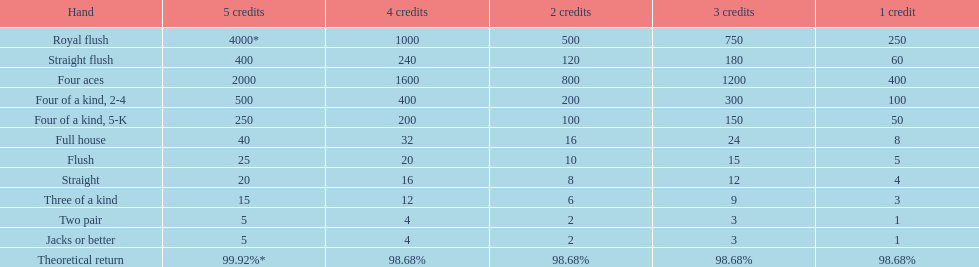Can a 2-credit full house be compared to a 5-credit three of a kind in terms of value? No. 